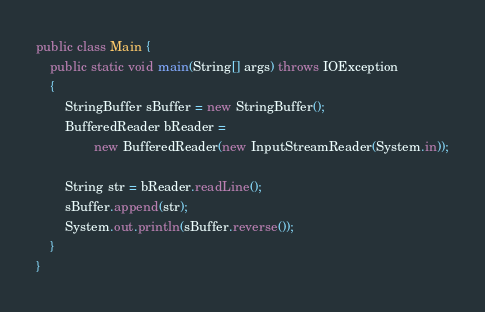<code> <loc_0><loc_0><loc_500><loc_500><_Java_>public class Main {
    public static void main(String[] args) throws IOException
    {
        StringBuffer sBuffer = new StringBuffer();
        BufferedReader bReader = 
                new BufferedReader(new InputStreamReader(System.in));
        
        String str = bReader.readLine();
        sBuffer.append(str);
        System.out.println(sBuffer.reverse());
    }
}</code> 